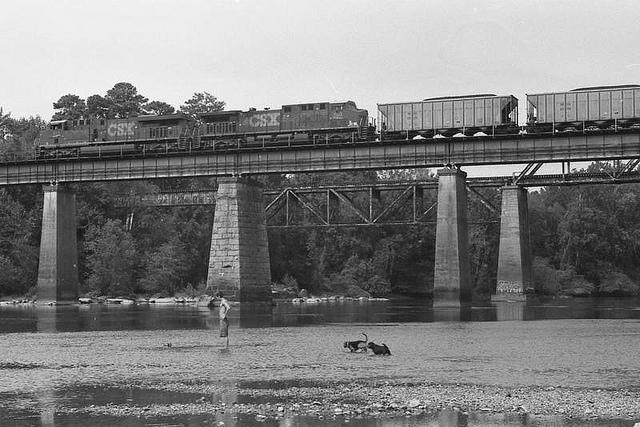What kind of animals are visible?
Write a very short answer. Dogs. Where is the person?
Be succinct. In water. Is the image in black and white?
Give a very brief answer. Yes. 